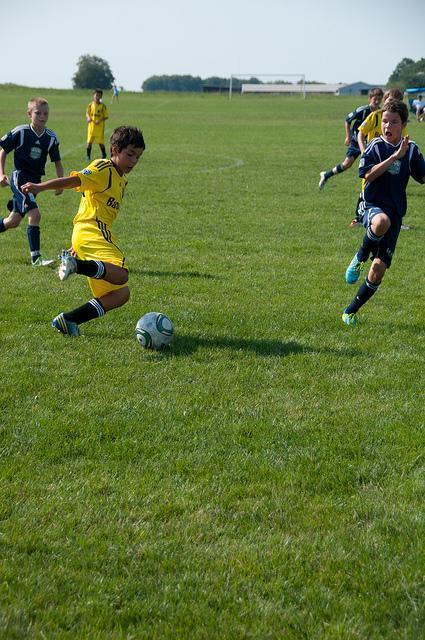How many boys are there?
Give a very brief answer. 6. How many people can you see?
Give a very brief answer. 3. 